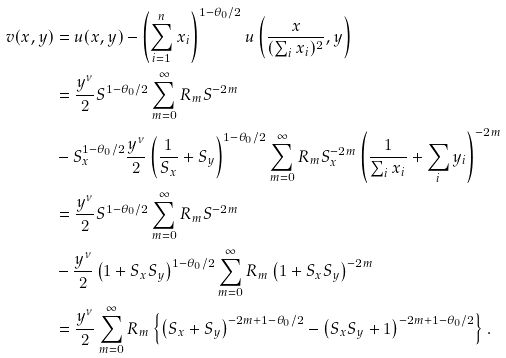Convert formula to latex. <formula><loc_0><loc_0><loc_500><loc_500>v ( x , y ) & = u ( x , y ) - \left ( \sum _ { i = 1 } ^ { n } x _ { i } \right ) ^ { 1 - \theta _ { 0 } / 2 } u \left ( \frac { x } { ( \sum _ { i } x _ { i } ) ^ { 2 } } , y \right ) \\ & = \frac { y ^ { \nu } } { 2 } S ^ { 1 - \theta _ { 0 } / 2 } \sum _ { m = 0 } ^ { \infty } R _ { m } S ^ { - 2 m } \\ & - S _ { x } ^ { 1 - \theta _ { 0 } / 2 } \frac { y ^ { \nu } } { 2 } \left ( \frac { 1 } { S _ { x } } + S _ { y } \right ) ^ { 1 - \theta _ { 0 } / 2 } \sum _ { m = 0 } ^ { \infty } R _ { m } S _ { x } ^ { - 2 m } \left ( \frac { 1 } { \sum _ { i } x _ { i } } + \sum _ { i } y _ { i } \right ) ^ { - 2 m } \\ & = \frac { y ^ { \nu } } { 2 } S ^ { 1 - \theta _ { 0 } / 2 } \sum _ { m = 0 } ^ { \infty } R _ { m } S ^ { - 2 m } \\ & - \frac { y ^ { \nu } } { 2 } \left ( 1 + S _ { x } S _ { y } \right ) ^ { 1 - \theta _ { 0 } / 2 } \sum _ { m = 0 } ^ { \infty } R _ { m } \left ( 1 + S _ { x } S _ { y } \right ) ^ { - 2 m } \\ & = \frac { y ^ { \nu } } { 2 } \sum _ { m = 0 } ^ { \infty } R _ { m } \left \{ \left ( S _ { x } + S _ { y } \right ) ^ { - 2 m + 1 - \theta _ { 0 } / 2 } - \left ( S _ { x } S _ { y } + 1 \right ) ^ { - 2 m + 1 - \theta _ { 0 } / 2 } \right \} .</formula> 